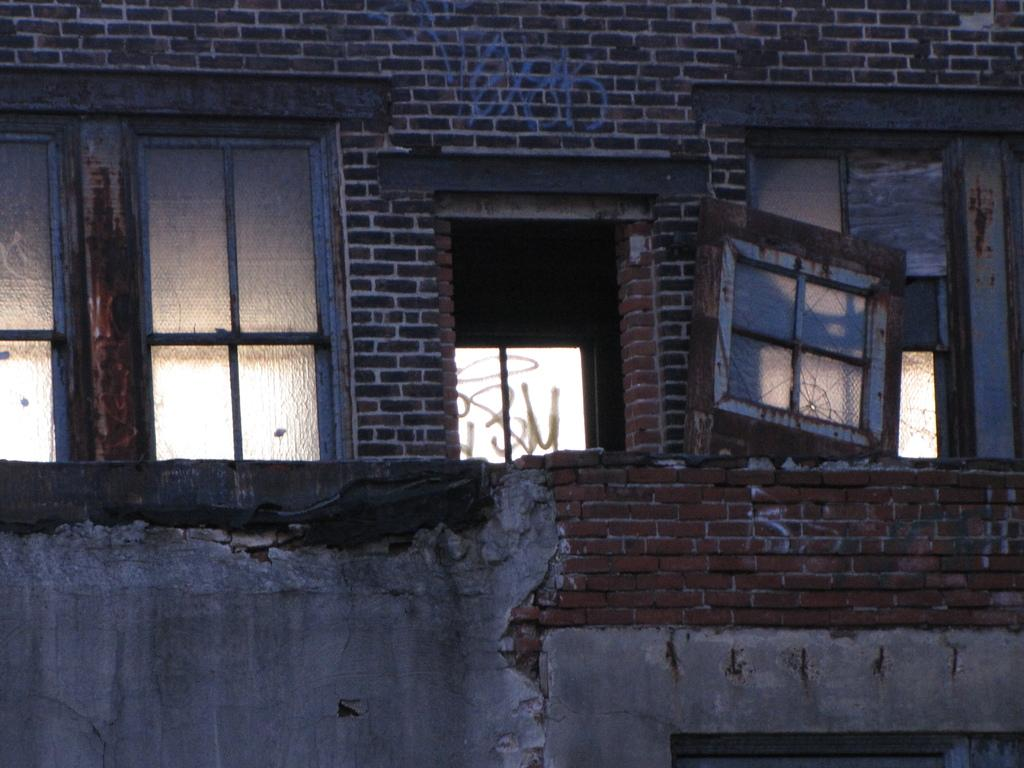What is the main subject of the image? The main subject of the image is a building. What architectural features can be seen on the building? There is a group of windows and a door on the building. What type of humor can be seen in the image? There is no humor present in the image, as it is a simple outside view of a building with windows and a door. 